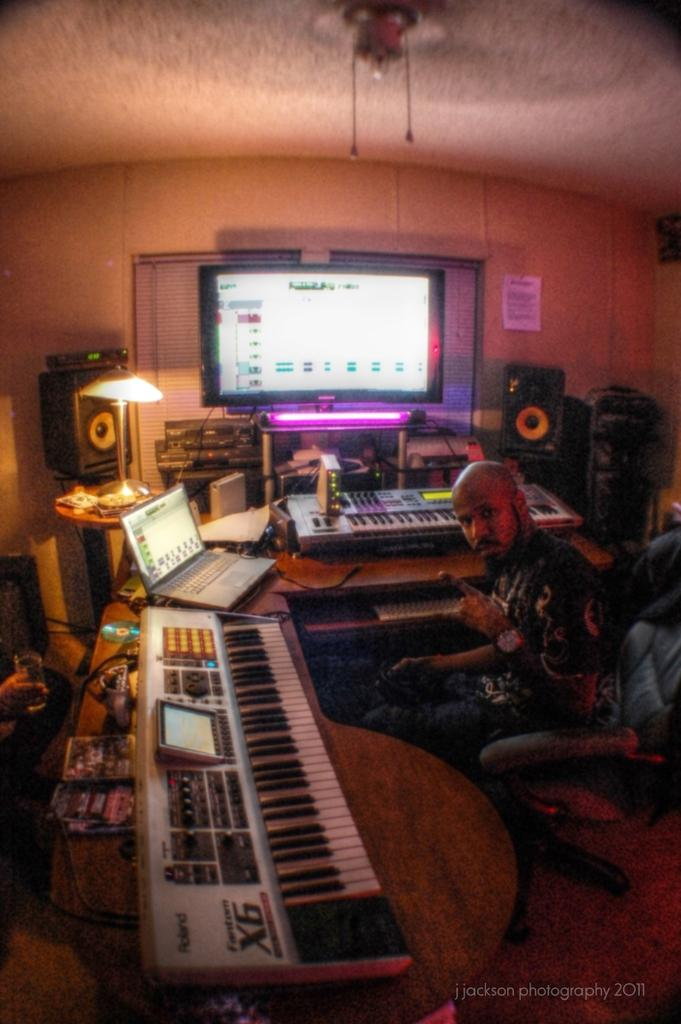What are the people in the room doing? The people are seated in the room. What are the people seated on? The people are seated on chairs. What electronic devices are in front of the people? There is a keyboard, a laptop, and a monitor in front of the people. What can be used to provide illumination in the room? There is a light in the room. What device might be used for amplifying sound in the room? There is a sound system in the room. What type of property is being discussed during the recess in the image? There is no indication of a recess or property discussion in the image; it shows people seated with electronic devices in front of them. 